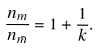<formula> <loc_0><loc_0><loc_500><loc_500>\frac { n _ { m } } { n _ { \bar { m } } } = 1 + \frac { 1 } { k } .</formula> 